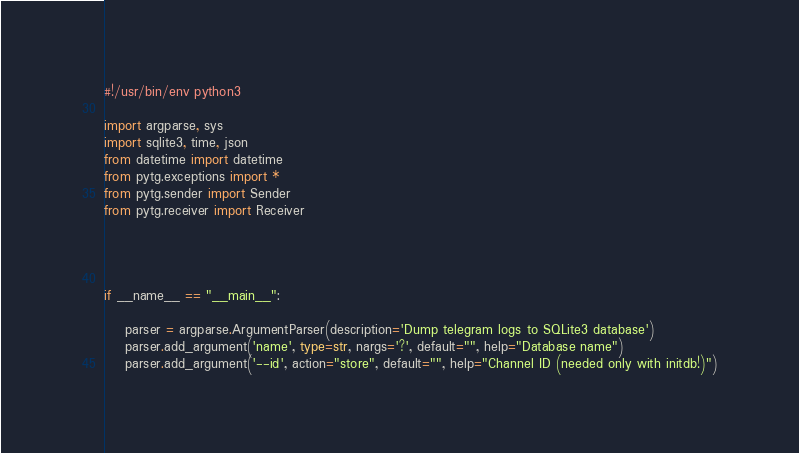Convert code to text. <code><loc_0><loc_0><loc_500><loc_500><_Python_>#!/usr/bin/env python3

import argparse, sys
import sqlite3, time, json
from datetime import datetime
from pytg.exceptions import *
from pytg.sender import Sender
from pytg.receiver import Receiver




if __name__ == "__main__":

    parser = argparse.ArgumentParser(description='Dump telegram logs to SQLite3 database')
    parser.add_argument('name', type=str, nargs='?', default="", help="Database name")
    parser.add_argument('--id', action="store", default="", help="Channel ID (needed only with initdb!)")</code> 